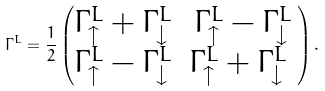Convert formula to latex. <formula><loc_0><loc_0><loc_500><loc_500>\Gamma ^ { L } = \frac { 1 } { 2 } \begin{pmatrix} \Gamma _ { \uparrow } ^ { L } + \Gamma _ { \downarrow } ^ { L } & \Gamma _ { \uparrow } ^ { L } - \Gamma _ { \downarrow } ^ { L } \\ \Gamma _ { \uparrow } ^ { L } - \Gamma _ { \downarrow } ^ { L } & \Gamma _ { \uparrow } ^ { L } + \Gamma _ { \downarrow } ^ { L } \ \end{pmatrix} .</formula> 